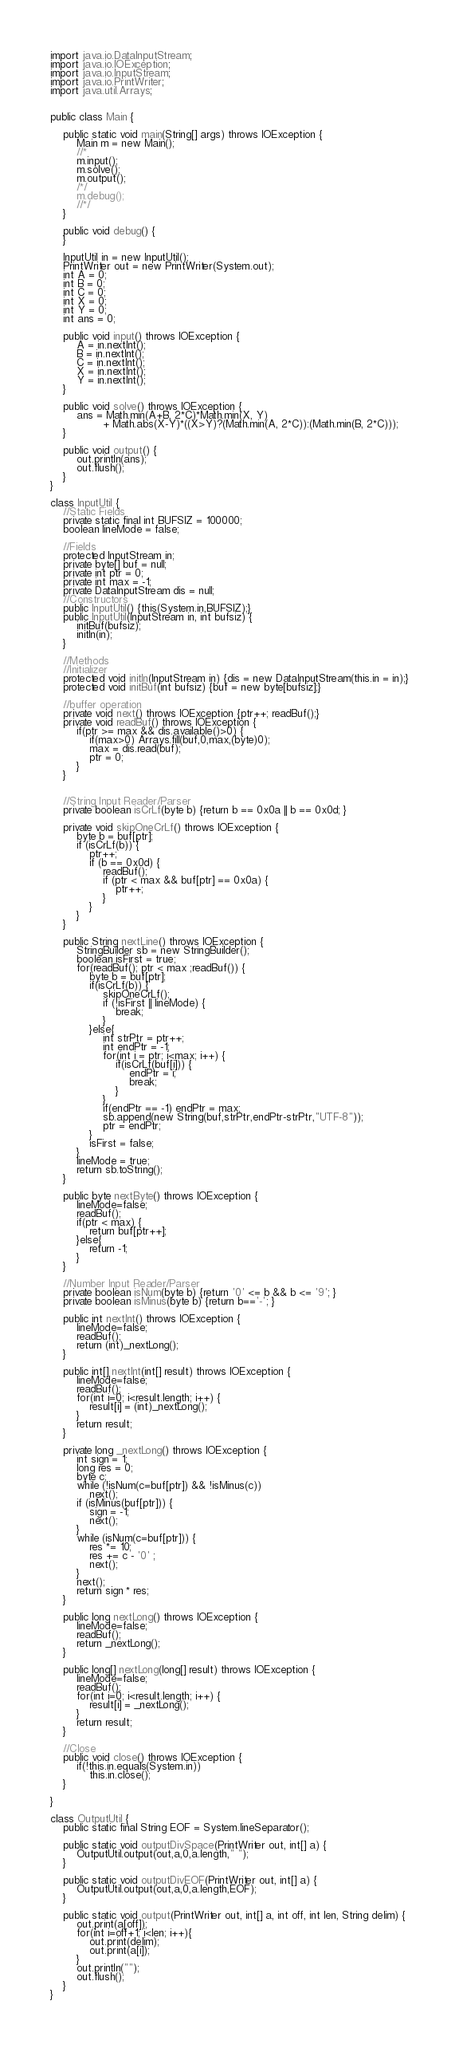Convert code to text. <code><loc_0><loc_0><loc_500><loc_500><_Java_>import java.io.DataInputStream;
import java.io.IOException;
import java.io.InputStream;
import java.io.PrintWriter;
import java.util.Arrays;


public class Main {
	
	public static void main(String[] args) throws IOException {
		Main m = new Main();
		//*
		m.input();
		m.solve();
		m.output();
		/*/
		m.debug();
		//*/
	}
	
	public void debug() {
	}
	
	InputUtil in = new InputUtil();
	PrintWriter out = new PrintWriter(System.out);
	int A = 0;
	int B = 0;
	int C = 0;
	int X = 0;
	int Y = 0;
	int ans = 0;

	public void input() throws IOException {
		A = in.nextInt();
		B = in.nextInt();
		C = in.nextInt();
		X = in.nextInt();
		Y = in.nextInt();
	}
	
	public void solve() throws IOException {
		ans = Math.min(A+B, 2*C)*Math.min(X, Y) 
				+ Math.abs(X-Y)*((X>Y)?(Math.min(A, 2*C)):(Math.min(B, 2*C)));
	}
	
	public void output() {
		out.println(ans);
		out.flush();
	}
}

class InputUtil {
	//Static Fields
	private static final int BUFSIZ = 100000;
	boolean lineMode = false;
	
	//Fields
	protected InputStream in;
	private byte[] buf = null;
	private int ptr = 0;
	private int max = -1;
	private DataInputStream dis = null;
	//Constructors
	public InputUtil() {this(System.in,BUFSIZ);}
	public InputUtil(InputStream in, int bufsiz) {
		initBuf(bufsiz);
		initIn(in);
	}
	
	//Methods
	//Initializer
	protected void initIn(InputStream in) {dis = new DataInputStream(this.in = in);}
	protected void initBuf(int bufsiz) {buf = new byte[bufsiz];}
	
	//buffer operation
	private void next() throws IOException {ptr++; readBuf();}
	private void readBuf() throws IOException {
		if(ptr >= max && dis.available()>0) {
			if(max>0) Arrays.fill(buf,0,max,(byte)0);
			max = dis.read(buf);
			ptr = 0;
		}
	}
	
	
	//String Input Reader/Parser
	private boolean isCrLf(byte b) {return b == 0x0a || b == 0x0d; }
	
	private void skipOneCrLf() throws IOException {
		byte b = buf[ptr];
		if (isCrLf(b)) {
			ptr++;
			if (b == 0x0d) {
				readBuf();
				if (ptr < max && buf[ptr] == 0x0a) {
					ptr++;
				}
			}
		}
	}
	
	public String nextLine() throws IOException {
		StringBuilder sb = new StringBuilder();
		boolean isFirst = true;
		for(readBuf(); ptr < max ;readBuf()) {
			byte b = buf[ptr];
			if(isCrLf(b)) {
				skipOneCrLf();
				if (!isFirst || lineMode) {
					break;
				}
			}else{
				int strPtr = ptr++;
				int endPtr = -1;
				for(int i = ptr; i<max; i++) {
					if(isCrLf(buf[i])) {
						endPtr = i;
						break;
					}
				}
				if(endPtr == -1) endPtr = max;
				sb.append(new String(buf,strPtr,endPtr-strPtr,"UTF-8"));
				ptr = endPtr;
			}
			isFirst = false;
		}
		lineMode = true;
		return sb.toString();
	}
	
	public byte nextByte() throws IOException {
		lineMode=false;
		readBuf();
		if(ptr < max) {
			return buf[ptr++];
		}else{
			return -1;
		}
	}
	
	//Number Input Reader/Parser
	private boolean isNum(byte b) {return '0' <= b && b <= '9'; }
	private boolean isMinus(byte b) {return b=='-'; }
	
	public int nextInt() throws IOException {
		lineMode=false;
		readBuf();
		return (int)_nextLong();
	}
	
	public int[] nextInt(int[] result) throws IOException {
		lineMode=false;
		readBuf();
		for(int i=0; i<result.length; i++) {
			result[i] = (int)_nextLong();
		}
		return result;
	}
	
	private long _nextLong() throws IOException {
		int sign = 1;
		long res = 0;
		byte c;
		while (!isNum(c=buf[ptr]) && !isMinus(c)) 
			next();
		if (isMinus(buf[ptr])) {
			sign = -1;
			next();
		}
		while (isNum(c=buf[ptr])) {
			res *= 10;
			res += c - '0' ;
			next();
		}
		next();
		return sign * res;
	}
	
	public long nextLong() throws IOException {
		lineMode=false;
		readBuf();
		return _nextLong();
	}
	
	public long[] nextLong(long[] result) throws IOException {
		lineMode=false;
		readBuf();
		for(int i=0; i<result.length; i++) {
			result[i] = _nextLong();
		}
		return result;
	}
	
	//Close 
	public void close() throws IOException {
		if(!this.in.equals(System.in)) 
			this.in.close();
	}

}

class OutputUtil {
	public static final String EOF = System.lineSeparator();

	public static void outputDivSpace(PrintWriter out, int[] a) {
		OutputUtil.output(out,a,0,a.length," ");
	}
	
	public static void outputDivEOF(PrintWriter out, int[] a) {
		OutputUtil.output(out,a,0,a.length,EOF);
	}
	
	public static void output(PrintWriter out, int[] a, int off, int len, String delim) {
		out.print(a[off]);
		for(int i=off+1; i<len; i++){
			out.print(delim);
			out.print(a[i]);
		}
		out.println("");
		out.flush();
	}
}
</code> 